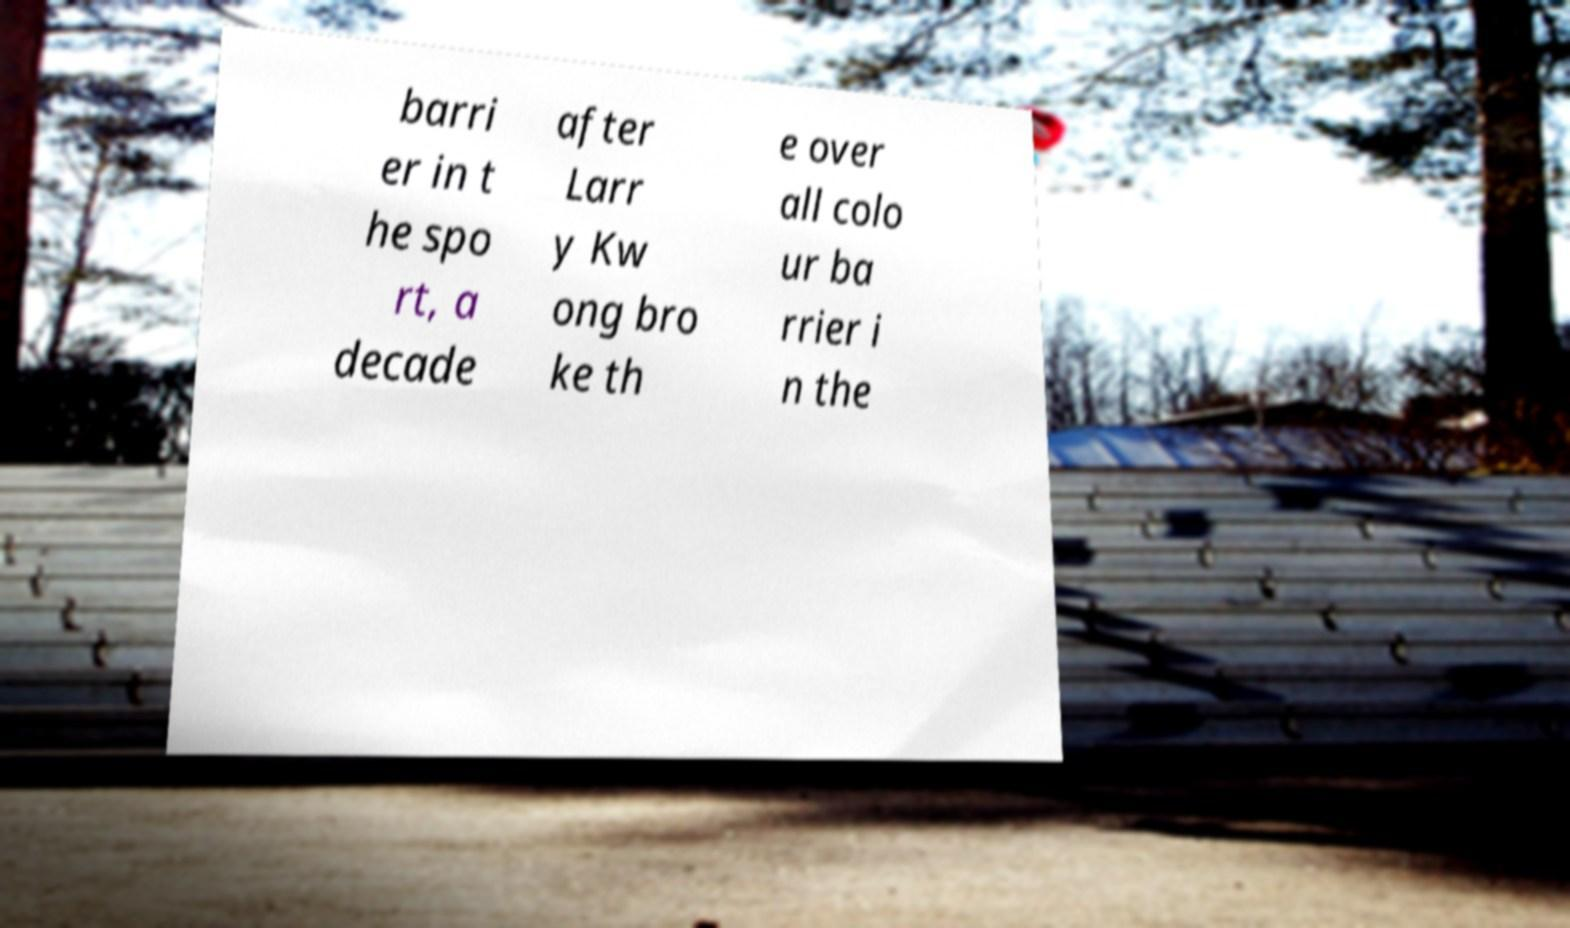I need the written content from this picture converted into text. Can you do that? barri er in t he spo rt, a decade after Larr y Kw ong bro ke th e over all colo ur ba rrier i n the 